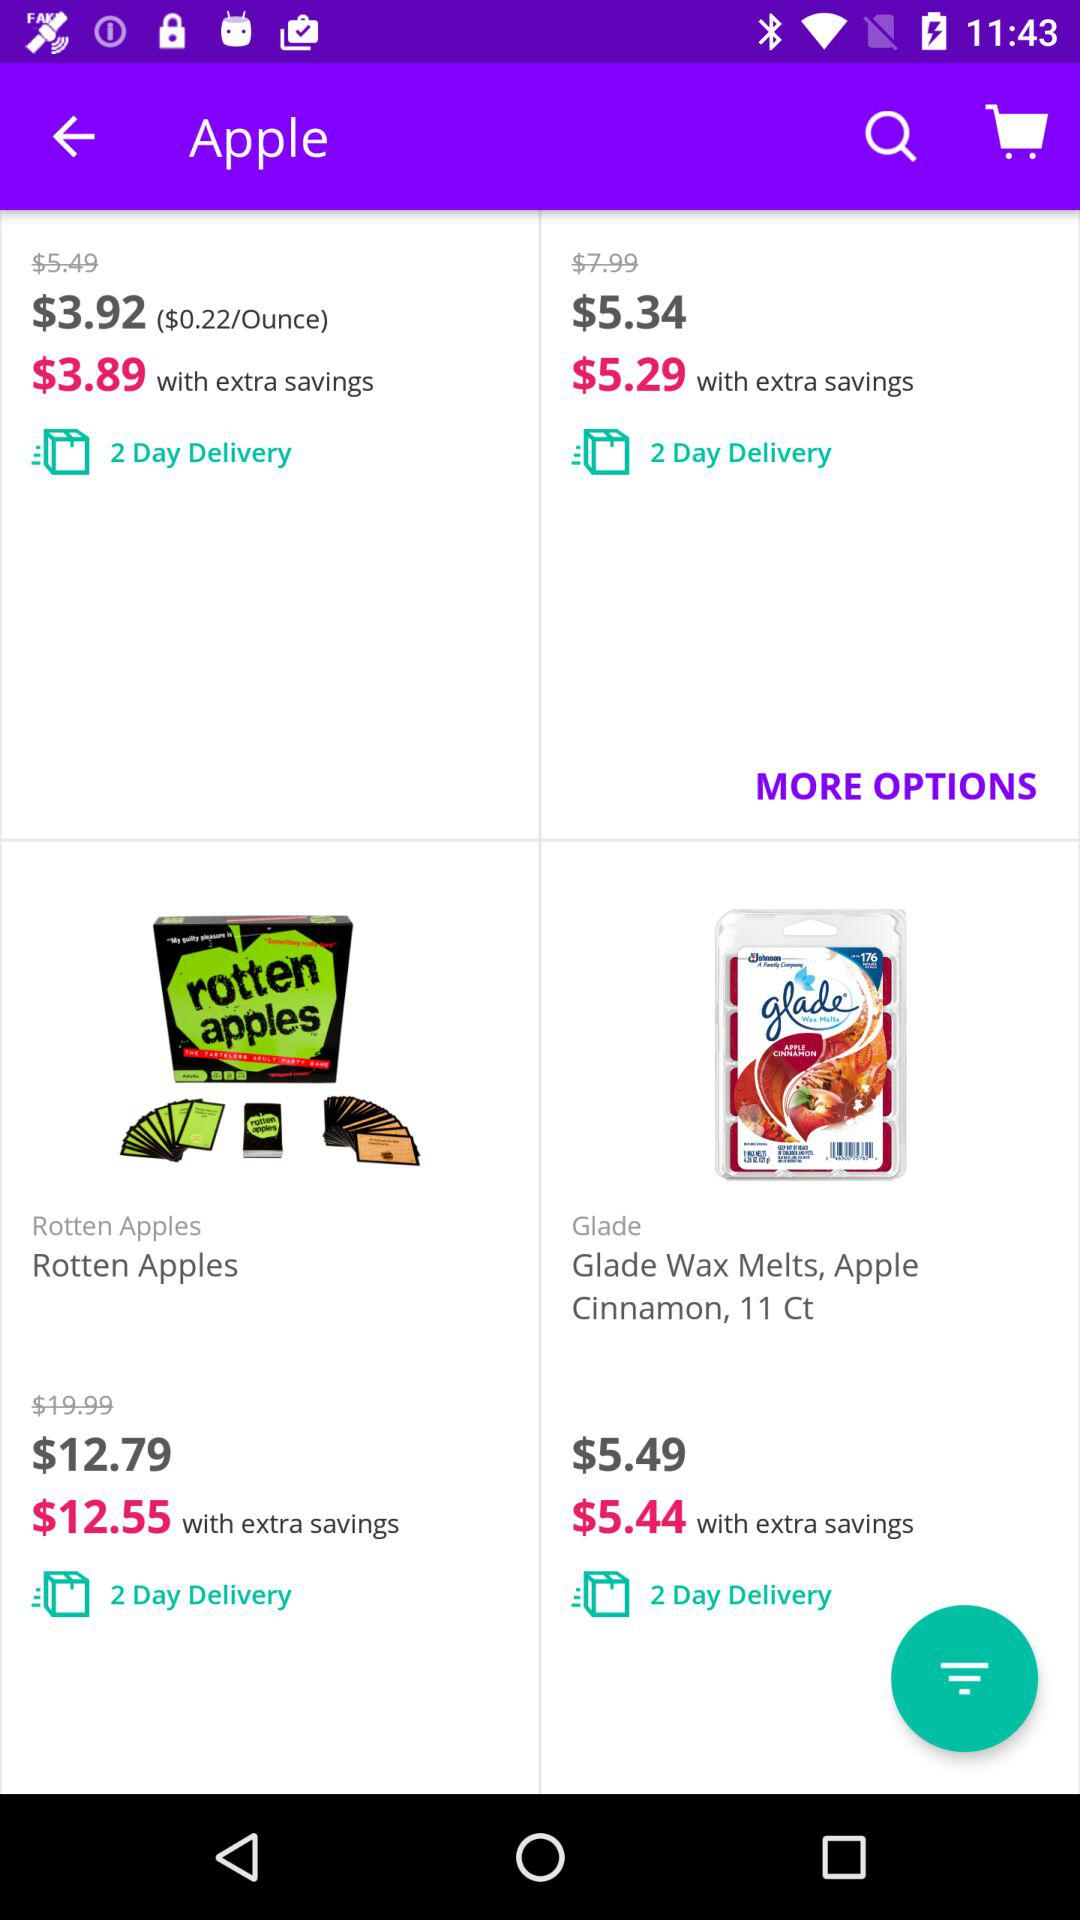What is the cost of rotten apples after the discount? The cost of rotten apples after the discount is $12.55. 